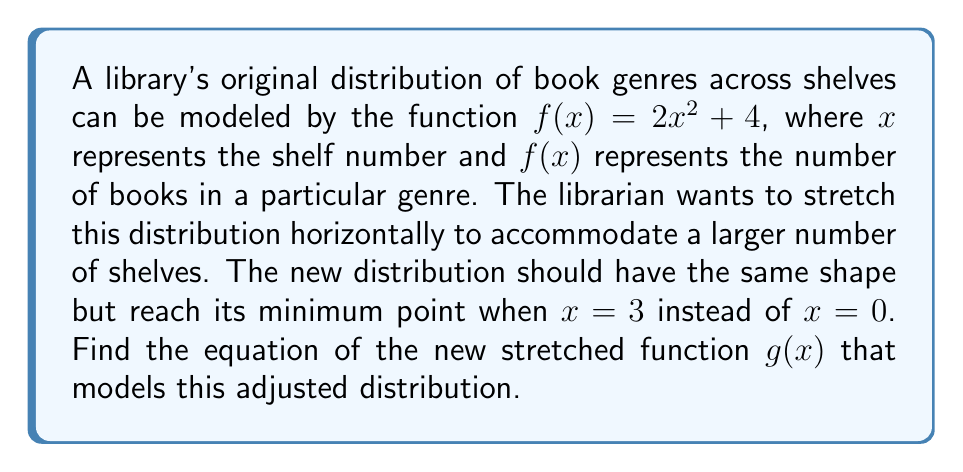Show me your answer to this math problem. To solve this problem, we need to apply a horizontal stretch to the original function $f(x) = 2x^2 + 4$. The steps are as follows:

1) The general form of a horizontal stretch is:
   $g(x) = f(\frac{x}{a})$, where $a$ is the stretch factor.

2) We know that the minimum point of the parabola should move from $x = 0$ to $x = 3$. This means we need to subtract 3 from $x$ before applying the function:
   $g(x) = f(\frac{x-3}{a})$

3) Substituting the original function:
   $g(x) = 2(\frac{x-3}{a})^2 + 4$

4) Expand this:
   $g(x) = 2(\frac{x^2-6x+9}{a^2}) + 4$
   $g(x) = \frac{2x^2-12x+18}{a^2} + 4$

5) To determine $a$, we can use the fact that the shape should remain the same. In the original function, the coefficient of $x^2$ is 2. In our new function, it should also be 2:

   $\frac{2}{a^2} = 2$

6) Solve for $a$:
   $a^2 = 1$
   $a = 1$ (we take the positive value as stretch factor is always positive)

7) Substitute $a = 1$ into our equation:
   $g(x) = \frac{2x^2-12x+18}{1^2} + 4$
   $g(x) = 2x^2-12x+18 + 4$
   $g(x) = 2x^2-12x+22$

This is the equation of the new stretched function that models the adjusted distribution of book genres across shelves.
Answer: $g(x) = 2x^2-12x+22$ 